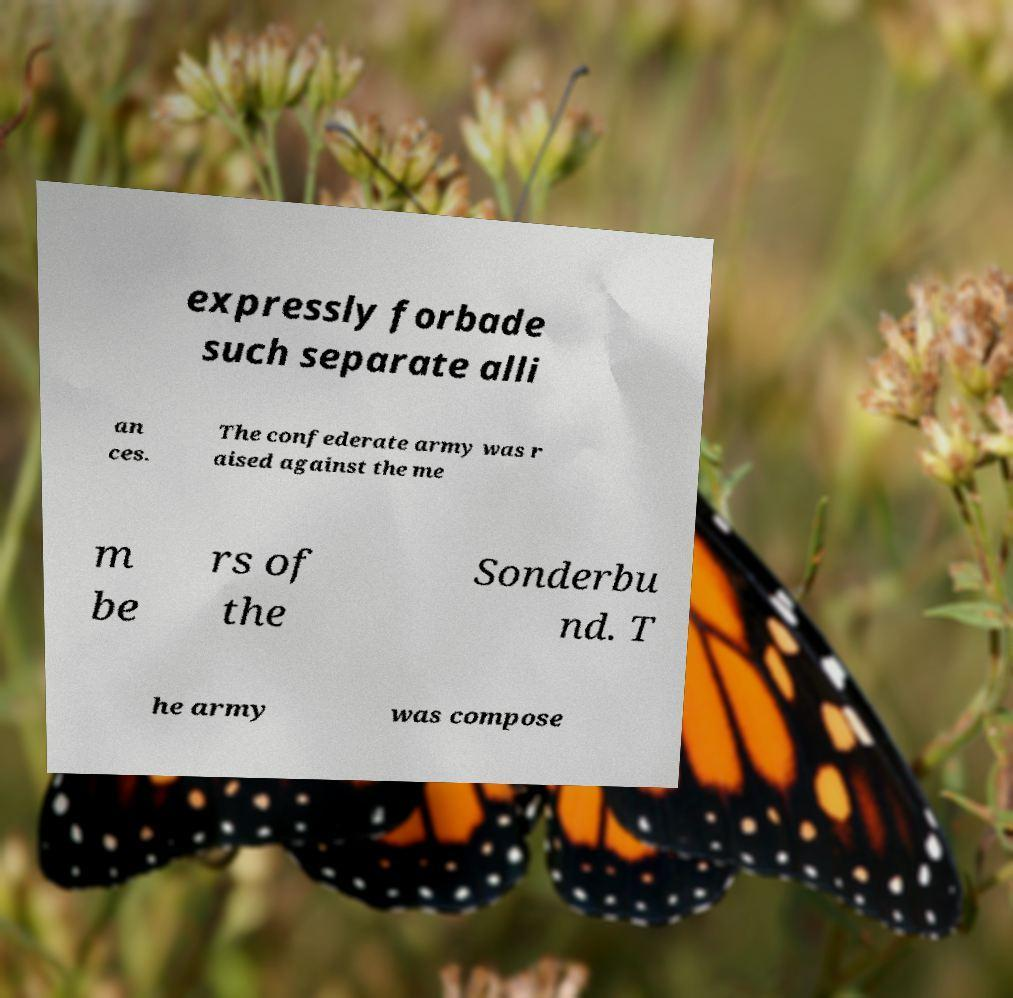I need the written content from this picture converted into text. Can you do that? expressly forbade such separate alli an ces. The confederate army was r aised against the me m be rs of the Sonderbu nd. T he army was compose 